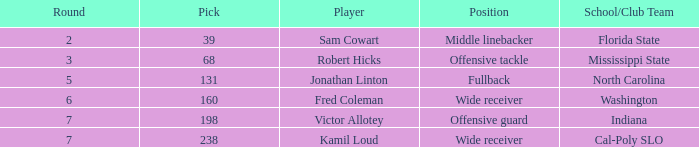In which round does a school/club team from indiana participate, with a pick number less than 198? None. 